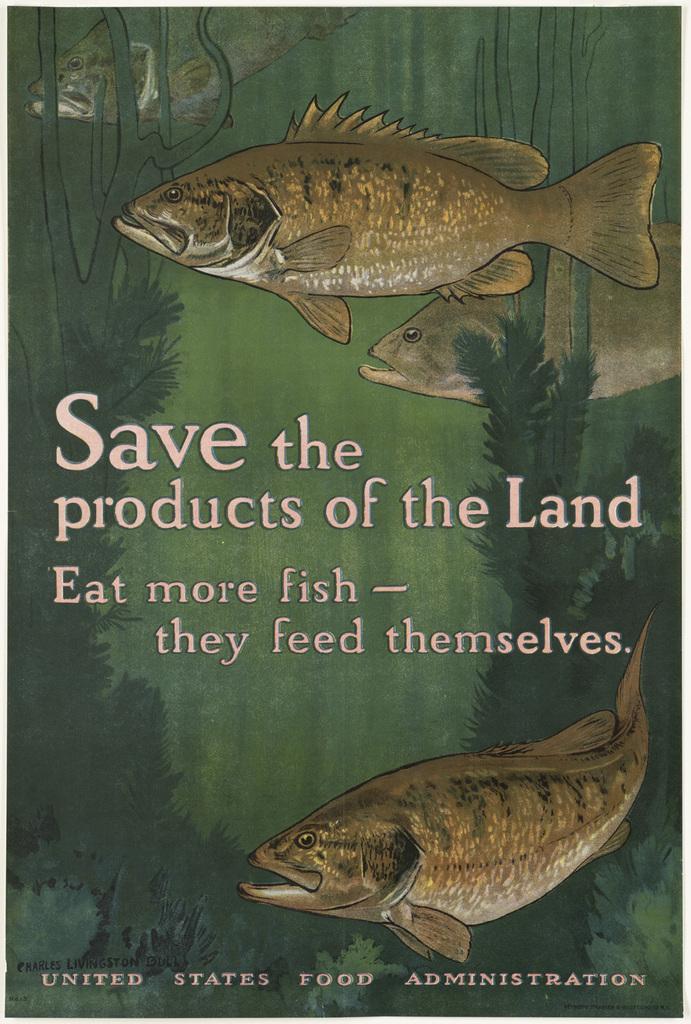Could you give a brief overview of what you see in this image? In this picture, we see the poster containing the fishes and the aquatic plants. At the bottom, we see the grass. In the middle of the picture, we see some text written. In the background, it is green in color. 